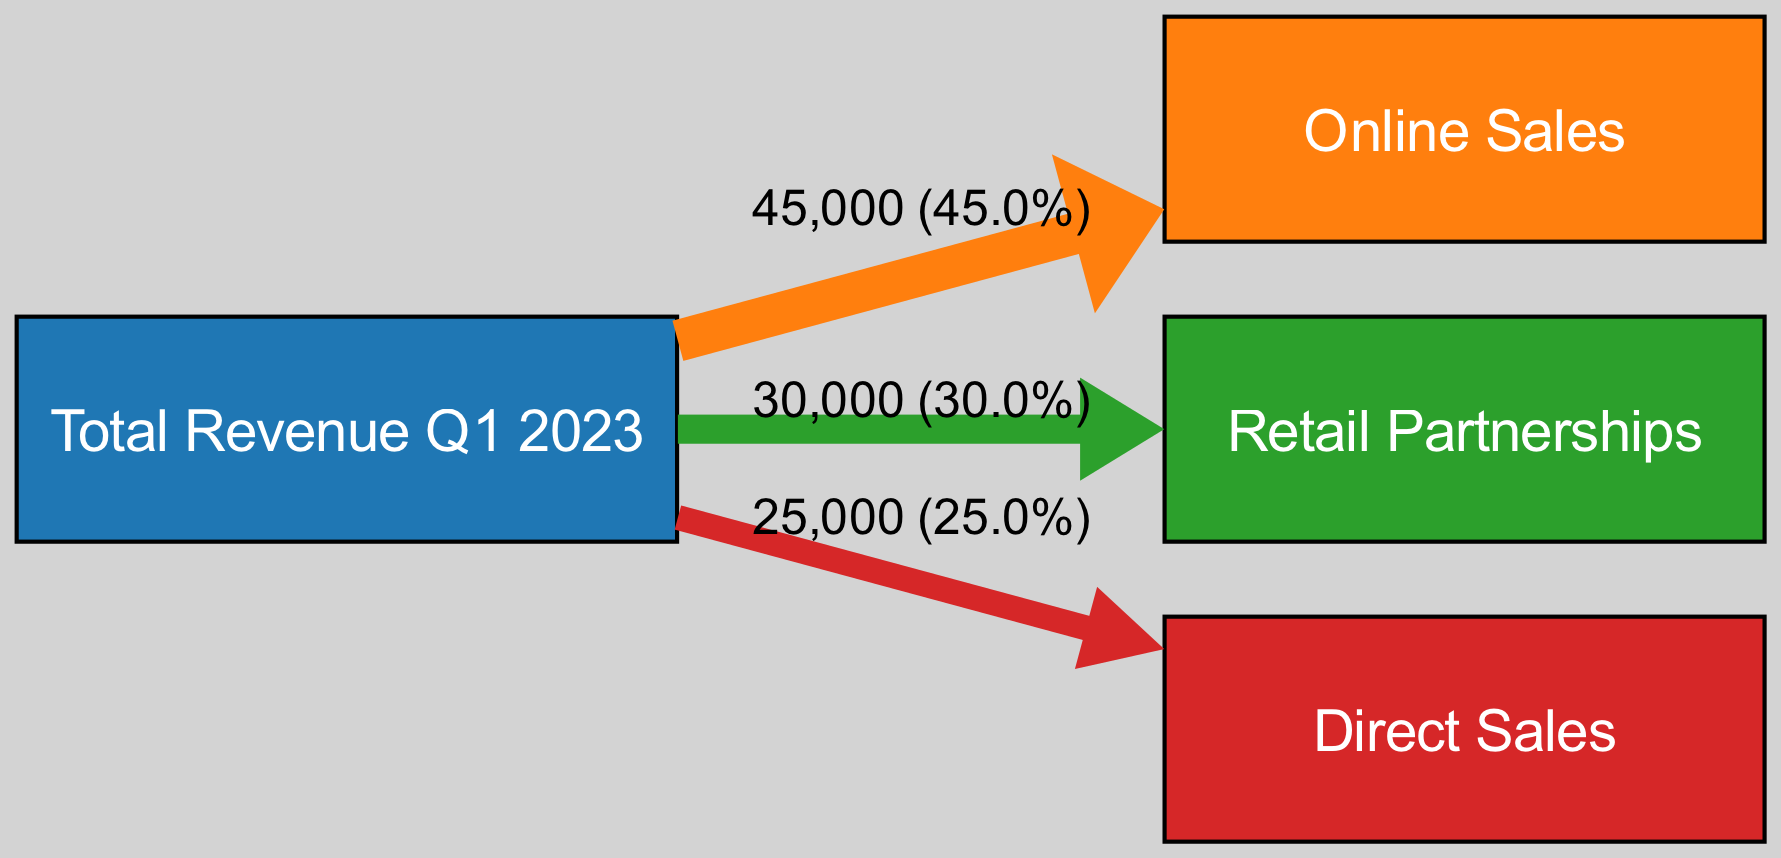What is the total revenue for Q1 2023? The diagram indicates that the total revenue for Q1 2023 is represented by the "Total Revenue" node. This node serves as the source for other nodes illustrating different sales channels. The total revenue value is shown to be 100,000.
Answer: 100,000 How much revenue was generated through online sales? The "Online Sales" node in the diagram displays a flow from "Total Revenue" with a value of 45,000. This value is directly shown on the edge connecting these two nodes, representing the income from online sales for Q1 2023.
Answer: 45,000 What sales channel generated the least revenue? By examining the links from the "Total Revenue" node to each sales channel, "Direct Sales" has the smallest value of 25,000. The link's size and the value indicated confirm that this channel has the lowest revenue among the three.
Answer: Direct Sales What percentage of the total revenue came from retail partnerships? The retail partnerships revenue of 30,000 needs to be calculated as a percentage of the total revenue (100,000). The formula is (30,000 / 100,000) * 100 = 30%. This calculation shows the relative contribution of retail partnerships to the total revenue.
Answer: 30% Which sales channel contributed more revenue: online sales or direct sales? To compare, online sales had a revenue of 45,000 while direct sales had 25,000. Since 45,000 is greater than 25,000, it is clear that online sales contributed more to the total revenue.
Answer: Online Sales How many total sales channels are displayed in the diagram? The diagram features three distinct sales channels: Online Sales, Retail Partnerships, and Direct Sales. The nodes for these three sales channels can be counted to reach the total number.
Answer: 3 What is the value of the flow from Total Revenue to Retail Partnerships? The flow from "Total Revenue" to "Retail Partnerships" represents the revenue generated through this sales channel. This value is indicated to be 30,000, detailed by the link connecting these nodes.
Answer: 30,000 What fraction of the total revenue is attributed to online sales? The flow value for online sales is 45,000. Dividing this by the total revenue (100,000) gives a fraction of 45,000 / 100,000 = 0.45. This indicates that online sales account for nearly half of the total revenue.
Answer: 0.45 